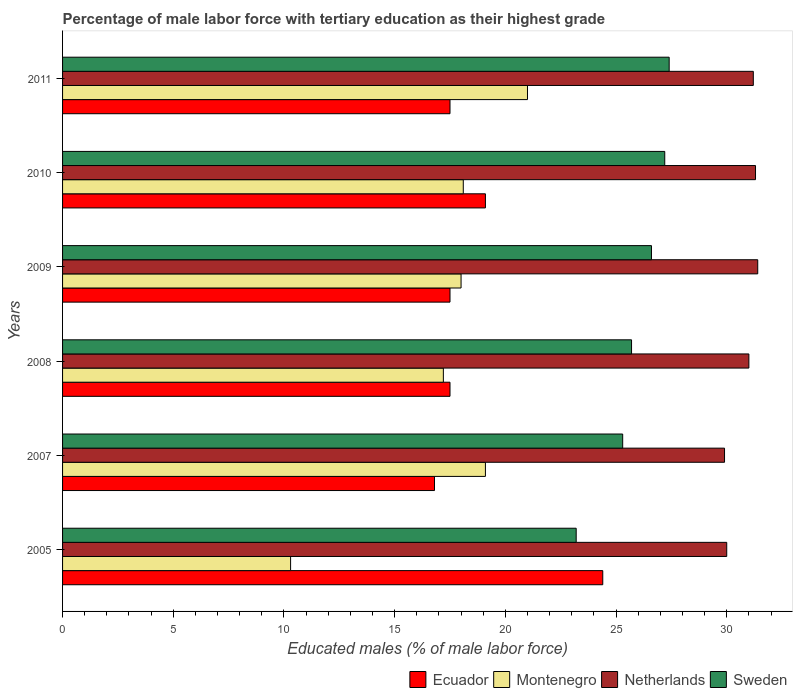How many different coloured bars are there?
Keep it short and to the point. 4. Are the number of bars on each tick of the Y-axis equal?
Keep it short and to the point. Yes. How many bars are there on the 3rd tick from the top?
Provide a short and direct response. 4. What is the percentage of male labor force with tertiary education in Ecuador in 2010?
Make the answer very short. 19.1. Across all years, what is the minimum percentage of male labor force with tertiary education in Sweden?
Offer a terse response. 23.2. In which year was the percentage of male labor force with tertiary education in Netherlands maximum?
Offer a very short reply. 2009. What is the total percentage of male labor force with tertiary education in Montenegro in the graph?
Provide a short and direct response. 103.7. What is the difference between the percentage of male labor force with tertiary education in Montenegro in 2007 and that in 2008?
Provide a succinct answer. 1.9. What is the difference between the percentage of male labor force with tertiary education in Montenegro in 2010 and the percentage of male labor force with tertiary education in Ecuador in 2005?
Keep it short and to the point. -6.3. What is the average percentage of male labor force with tertiary education in Montenegro per year?
Offer a terse response. 17.28. In the year 2010, what is the difference between the percentage of male labor force with tertiary education in Sweden and percentage of male labor force with tertiary education in Netherlands?
Give a very brief answer. -4.1. In how many years, is the percentage of male labor force with tertiary education in Montenegro greater than 25 %?
Your answer should be very brief. 0. What is the ratio of the percentage of male labor force with tertiary education in Sweden in 2010 to that in 2011?
Your response must be concise. 0.99. Is the percentage of male labor force with tertiary education in Ecuador in 2005 less than that in 2007?
Ensure brevity in your answer.  No. Is the difference between the percentage of male labor force with tertiary education in Sweden in 2007 and 2010 greater than the difference between the percentage of male labor force with tertiary education in Netherlands in 2007 and 2010?
Provide a succinct answer. No. What is the difference between the highest and the second highest percentage of male labor force with tertiary education in Sweden?
Provide a succinct answer. 0.2. What is the difference between the highest and the lowest percentage of male labor force with tertiary education in Ecuador?
Offer a terse response. 7.6. Is the sum of the percentage of male labor force with tertiary education in Sweden in 2005 and 2010 greater than the maximum percentage of male labor force with tertiary education in Montenegro across all years?
Your answer should be very brief. Yes. Is it the case that in every year, the sum of the percentage of male labor force with tertiary education in Montenegro and percentage of male labor force with tertiary education in Sweden is greater than the sum of percentage of male labor force with tertiary education in Ecuador and percentage of male labor force with tertiary education in Netherlands?
Provide a succinct answer. No. What does the 4th bar from the bottom in 2011 represents?
Your answer should be very brief. Sweden. Is it the case that in every year, the sum of the percentage of male labor force with tertiary education in Netherlands and percentage of male labor force with tertiary education in Ecuador is greater than the percentage of male labor force with tertiary education in Sweden?
Keep it short and to the point. Yes. What is the difference between two consecutive major ticks on the X-axis?
Provide a succinct answer. 5. Are the values on the major ticks of X-axis written in scientific E-notation?
Provide a succinct answer. No. Where does the legend appear in the graph?
Make the answer very short. Bottom right. How many legend labels are there?
Your answer should be compact. 4. How are the legend labels stacked?
Provide a short and direct response. Horizontal. What is the title of the graph?
Keep it short and to the point. Percentage of male labor force with tertiary education as their highest grade. Does "Marshall Islands" appear as one of the legend labels in the graph?
Your response must be concise. No. What is the label or title of the X-axis?
Keep it short and to the point. Educated males (% of male labor force). What is the Educated males (% of male labor force) in Ecuador in 2005?
Your answer should be very brief. 24.4. What is the Educated males (% of male labor force) in Montenegro in 2005?
Offer a very short reply. 10.3. What is the Educated males (% of male labor force) of Sweden in 2005?
Provide a succinct answer. 23.2. What is the Educated males (% of male labor force) of Ecuador in 2007?
Offer a terse response. 16.8. What is the Educated males (% of male labor force) of Montenegro in 2007?
Provide a short and direct response. 19.1. What is the Educated males (% of male labor force) of Netherlands in 2007?
Provide a short and direct response. 29.9. What is the Educated males (% of male labor force) in Sweden in 2007?
Your response must be concise. 25.3. What is the Educated males (% of male labor force) in Ecuador in 2008?
Keep it short and to the point. 17.5. What is the Educated males (% of male labor force) in Montenegro in 2008?
Offer a very short reply. 17.2. What is the Educated males (% of male labor force) in Netherlands in 2008?
Provide a succinct answer. 31. What is the Educated males (% of male labor force) in Sweden in 2008?
Make the answer very short. 25.7. What is the Educated males (% of male labor force) of Montenegro in 2009?
Your answer should be compact. 18. What is the Educated males (% of male labor force) of Netherlands in 2009?
Provide a short and direct response. 31.4. What is the Educated males (% of male labor force) in Sweden in 2009?
Ensure brevity in your answer.  26.6. What is the Educated males (% of male labor force) in Ecuador in 2010?
Offer a terse response. 19.1. What is the Educated males (% of male labor force) in Montenegro in 2010?
Keep it short and to the point. 18.1. What is the Educated males (% of male labor force) in Netherlands in 2010?
Ensure brevity in your answer.  31.3. What is the Educated males (% of male labor force) of Sweden in 2010?
Keep it short and to the point. 27.2. What is the Educated males (% of male labor force) in Netherlands in 2011?
Give a very brief answer. 31.2. What is the Educated males (% of male labor force) in Sweden in 2011?
Provide a short and direct response. 27.4. Across all years, what is the maximum Educated males (% of male labor force) in Ecuador?
Your answer should be very brief. 24.4. Across all years, what is the maximum Educated males (% of male labor force) in Montenegro?
Provide a succinct answer. 21. Across all years, what is the maximum Educated males (% of male labor force) of Netherlands?
Offer a terse response. 31.4. Across all years, what is the maximum Educated males (% of male labor force) of Sweden?
Provide a succinct answer. 27.4. Across all years, what is the minimum Educated males (% of male labor force) in Ecuador?
Give a very brief answer. 16.8. Across all years, what is the minimum Educated males (% of male labor force) in Montenegro?
Your answer should be compact. 10.3. Across all years, what is the minimum Educated males (% of male labor force) in Netherlands?
Provide a succinct answer. 29.9. Across all years, what is the minimum Educated males (% of male labor force) in Sweden?
Make the answer very short. 23.2. What is the total Educated males (% of male labor force) in Ecuador in the graph?
Keep it short and to the point. 112.8. What is the total Educated males (% of male labor force) in Montenegro in the graph?
Ensure brevity in your answer.  103.7. What is the total Educated males (% of male labor force) in Netherlands in the graph?
Provide a short and direct response. 184.8. What is the total Educated males (% of male labor force) of Sweden in the graph?
Your response must be concise. 155.4. What is the difference between the Educated males (% of male labor force) in Montenegro in 2005 and that in 2007?
Provide a short and direct response. -8.8. What is the difference between the Educated males (% of male labor force) in Sweden in 2005 and that in 2007?
Provide a succinct answer. -2.1. What is the difference between the Educated males (% of male labor force) in Ecuador in 2005 and that in 2008?
Your answer should be very brief. 6.9. What is the difference between the Educated males (% of male labor force) of Montenegro in 2005 and that in 2008?
Your answer should be very brief. -6.9. What is the difference between the Educated males (% of male labor force) in Netherlands in 2005 and that in 2008?
Offer a terse response. -1. What is the difference between the Educated males (% of male labor force) in Sweden in 2005 and that in 2008?
Offer a very short reply. -2.5. What is the difference between the Educated males (% of male labor force) of Netherlands in 2005 and that in 2010?
Give a very brief answer. -1.3. What is the difference between the Educated males (% of male labor force) of Sweden in 2005 and that in 2010?
Offer a very short reply. -4. What is the difference between the Educated males (% of male labor force) in Ecuador in 2005 and that in 2011?
Your answer should be very brief. 6.9. What is the difference between the Educated males (% of male labor force) of Netherlands in 2005 and that in 2011?
Make the answer very short. -1.2. What is the difference between the Educated males (% of male labor force) of Montenegro in 2007 and that in 2008?
Provide a succinct answer. 1.9. What is the difference between the Educated males (% of male labor force) of Netherlands in 2007 and that in 2008?
Your response must be concise. -1.1. What is the difference between the Educated males (% of male labor force) of Sweden in 2007 and that in 2008?
Make the answer very short. -0.4. What is the difference between the Educated males (% of male labor force) of Ecuador in 2007 and that in 2009?
Make the answer very short. -0.7. What is the difference between the Educated males (% of male labor force) of Montenegro in 2007 and that in 2009?
Ensure brevity in your answer.  1.1. What is the difference between the Educated males (% of male labor force) of Sweden in 2007 and that in 2009?
Offer a terse response. -1.3. What is the difference between the Educated males (% of male labor force) in Montenegro in 2007 and that in 2010?
Provide a short and direct response. 1. What is the difference between the Educated males (% of male labor force) of Ecuador in 2007 and that in 2011?
Your answer should be compact. -0.7. What is the difference between the Educated males (% of male labor force) of Montenegro in 2007 and that in 2011?
Ensure brevity in your answer.  -1.9. What is the difference between the Educated males (% of male labor force) of Montenegro in 2008 and that in 2009?
Offer a terse response. -0.8. What is the difference between the Educated males (% of male labor force) of Sweden in 2008 and that in 2009?
Provide a succinct answer. -0.9. What is the difference between the Educated males (% of male labor force) in Ecuador in 2008 and that in 2010?
Provide a succinct answer. -1.6. What is the difference between the Educated males (% of male labor force) in Netherlands in 2008 and that in 2010?
Make the answer very short. -0.3. What is the difference between the Educated males (% of male labor force) of Montenegro in 2008 and that in 2011?
Keep it short and to the point. -3.8. What is the difference between the Educated males (% of male labor force) in Netherlands in 2008 and that in 2011?
Your answer should be compact. -0.2. What is the difference between the Educated males (% of male labor force) in Sweden in 2008 and that in 2011?
Make the answer very short. -1.7. What is the difference between the Educated males (% of male labor force) of Ecuador in 2009 and that in 2010?
Offer a terse response. -1.6. What is the difference between the Educated males (% of male labor force) of Ecuador in 2009 and that in 2011?
Give a very brief answer. 0. What is the difference between the Educated males (% of male labor force) in Ecuador in 2010 and that in 2011?
Give a very brief answer. 1.6. What is the difference between the Educated males (% of male labor force) in Montenegro in 2010 and that in 2011?
Your answer should be very brief. -2.9. What is the difference between the Educated males (% of male labor force) in Sweden in 2010 and that in 2011?
Provide a succinct answer. -0.2. What is the difference between the Educated males (% of male labor force) in Ecuador in 2005 and the Educated males (% of male labor force) in Montenegro in 2007?
Make the answer very short. 5.3. What is the difference between the Educated males (% of male labor force) of Ecuador in 2005 and the Educated males (% of male labor force) of Netherlands in 2007?
Your answer should be very brief. -5.5. What is the difference between the Educated males (% of male labor force) in Ecuador in 2005 and the Educated males (% of male labor force) in Sweden in 2007?
Offer a terse response. -0.9. What is the difference between the Educated males (% of male labor force) in Montenegro in 2005 and the Educated males (% of male labor force) in Netherlands in 2007?
Keep it short and to the point. -19.6. What is the difference between the Educated males (% of male labor force) of Netherlands in 2005 and the Educated males (% of male labor force) of Sweden in 2007?
Your response must be concise. 4.7. What is the difference between the Educated males (% of male labor force) in Ecuador in 2005 and the Educated males (% of male labor force) in Netherlands in 2008?
Make the answer very short. -6.6. What is the difference between the Educated males (% of male labor force) of Montenegro in 2005 and the Educated males (% of male labor force) of Netherlands in 2008?
Your response must be concise. -20.7. What is the difference between the Educated males (% of male labor force) in Montenegro in 2005 and the Educated males (% of male labor force) in Sweden in 2008?
Your answer should be compact. -15.4. What is the difference between the Educated males (% of male labor force) in Netherlands in 2005 and the Educated males (% of male labor force) in Sweden in 2008?
Your answer should be very brief. 4.3. What is the difference between the Educated males (% of male labor force) of Ecuador in 2005 and the Educated males (% of male labor force) of Montenegro in 2009?
Provide a succinct answer. 6.4. What is the difference between the Educated males (% of male labor force) in Ecuador in 2005 and the Educated males (% of male labor force) in Netherlands in 2009?
Ensure brevity in your answer.  -7. What is the difference between the Educated males (% of male labor force) in Montenegro in 2005 and the Educated males (% of male labor force) in Netherlands in 2009?
Ensure brevity in your answer.  -21.1. What is the difference between the Educated males (% of male labor force) in Montenegro in 2005 and the Educated males (% of male labor force) in Sweden in 2009?
Keep it short and to the point. -16.3. What is the difference between the Educated males (% of male labor force) in Ecuador in 2005 and the Educated males (% of male labor force) in Montenegro in 2010?
Give a very brief answer. 6.3. What is the difference between the Educated males (% of male labor force) of Montenegro in 2005 and the Educated males (% of male labor force) of Sweden in 2010?
Keep it short and to the point. -16.9. What is the difference between the Educated males (% of male labor force) in Netherlands in 2005 and the Educated males (% of male labor force) in Sweden in 2010?
Provide a short and direct response. 2.8. What is the difference between the Educated males (% of male labor force) in Ecuador in 2005 and the Educated males (% of male labor force) in Netherlands in 2011?
Ensure brevity in your answer.  -6.8. What is the difference between the Educated males (% of male labor force) of Ecuador in 2005 and the Educated males (% of male labor force) of Sweden in 2011?
Ensure brevity in your answer.  -3. What is the difference between the Educated males (% of male labor force) in Montenegro in 2005 and the Educated males (% of male labor force) in Netherlands in 2011?
Make the answer very short. -20.9. What is the difference between the Educated males (% of male labor force) in Montenegro in 2005 and the Educated males (% of male labor force) in Sweden in 2011?
Provide a short and direct response. -17.1. What is the difference between the Educated males (% of male labor force) of Ecuador in 2007 and the Educated males (% of male labor force) of Netherlands in 2008?
Keep it short and to the point. -14.2. What is the difference between the Educated males (% of male labor force) of Ecuador in 2007 and the Educated males (% of male labor force) of Sweden in 2008?
Give a very brief answer. -8.9. What is the difference between the Educated males (% of male labor force) of Montenegro in 2007 and the Educated males (% of male labor force) of Sweden in 2008?
Offer a very short reply. -6.6. What is the difference between the Educated males (% of male labor force) of Ecuador in 2007 and the Educated males (% of male labor force) of Netherlands in 2009?
Keep it short and to the point. -14.6. What is the difference between the Educated males (% of male labor force) in Montenegro in 2007 and the Educated males (% of male labor force) in Netherlands in 2009?
Your answer should be very brief. -12.3. What is the difference between the Educated males (% of male labor force) of Montenegro in 2007 and the Educated males (% of male labor force) of Sweden in 2009?
Ensure brevity in your answer.  -7.5. What is the difference between the Educated males (% of male labor force) in Ecuador in 2007 and the Educated males (% of male labor force) in Montenegro in 2010?
Provide a succinct answer. -1.3. What is the difference between the Educated males (% of male labor force) of Ecuador in 2007 and the Educated males (% of male labor force) of Sweden in 2010?
Your response must be concise. -10.4. What is the difference between the Educated males (% of male labor force) of Montenegro in 2007 and the Educated males (% of male labor force) of Netherlands in 2010?
Give a very brief answer. -12.2. What is the difference between the Educated males (% of male labor force) of Ecuador in 2007 and the Educated males (% of male labor force) of Netherlands in 2011?
Provide a succinct answer. -14.4. What is the difference between the Educated males (% of male labor force) in Ecuador in 2007 and the Educated males (% of male labor force) in Sweden in 2011?
Give a very brief answer. -10.6. What is the difference between the Educated males (% of male labor force) of Montenegro in 2007 and the Educated males (% of male labor force) of Netherlands in 2011?
Offer a very short reply. -12.1. What is the difference between the Educated males (% of male labor force) in Montenegro in 2007 and the Educated males (% of male labor force) in Sweden in 2011?
Your answer should be compact. -8.3. What is the difference between the Educated males (% of male labor force) in Ecuador in 2008 and the Educated males (% of male labor force) in Montenegro in 2009?
Provide a short and direct response. -0.5. What is the difference between the Educated males (% of male labor force) in Montenegro in 2008 and the Educated males (% of male labor force) in Netherlands in 2009?
Ensure brevity in your answer.  -14.2. What is the difference between the Educated males (% of male labor force) of Montenegro in 2008 and the Educated males (% of male labor force) of Sweden in 2009?
Your answer should be very brief. -9.4. What is the difference between the Educated males (% of male labor force) in Netherlands in 2008 and the Educated males (% of male labor force) in Sweden in 2009?
Your answer should be very brief. 4.4. What is the difference between the Educated males (% of male labor force) of Ecuador in 2008 and the Educated males (% of male labor force) of Montenegro in 2010?
Give a very brief answer. -0.6. What is the difference between the Educated males (% of male labor force) in Ecuador in 2008 and the Educated males (% of male labor force) in Sweden in 2010?
Make the answer very short. -9.7. What is the difference between the Educated males (% of male labor force) of Montenegro in 2008 and the Educated males (% of male labor force) of Netherlands in 2010?
Provide a succinct answer. -14.1. What is the difference between the Educated males (% of male labor force) of Montenegro in 2008 and the Educated males (% of male labor force) of Sweden in 2010?
Keep it short and to the point. -10. What is the difference between the Educated males (% of male labor force) in Netherlands in 2008 and the Educated males (% of male labor force) in Sweden in 2010?
Give a very brief answer. 3.8. What is the difference between the Educated males (% of male labor force) in Ecuador in 2008 and the Educated males (% of male labor force) in Netherlands in 2011?
Provide a short and direct response. -13.7. What is the difference between the Educated males (% of male labor force) in Montenegro in 2008 and the Educated males (% of male labor force) in Netherlands in 2011?
Give a very brief answer. -14. What is the difference between the Educated males (% of male labor force) in Montenegro in 2008 and the Educated males (% of male labor force) in Sweden in 2011?
Keep it short and to the point. -10.2. What is the difference between the Educated males (% of male labor force) of Ecuador in 2009 and the Educated males (% of male labor force) of Montenegro in 2010?
Offer a terse response. -0.6. What is the difference between the Educated males (% of male labor force) of Montenegro in 2009 and the Educated males (% of male labor force) of Sweden in 2010?
Ensure brevity in your answer.  -9.2. What is the difference between the Educated males (% of male labor force) in Netherlands in 2009 and the Educated males (% of male labor force) in Sweden in 2010?
Provide a succinct answer. 4.2. What is the difference between the Educated males (% of male labor force) in Ecuador in 2009 and the Educated males (% of male labor force) in Netherlands in 2011?
Give a very brief answer. -13.7. What is the difference between the Educated males (% of male labor force) in Montenegro in 2009 and the Educated males (% of male labor force) in Netherlands in 2011?
Your response must be concise. -13.2. What is the difference between the Educated males (% of male labor force) of Ecuador in 2010 and the Educated males (% of male labor force) of Netherlands in 2011?
Give a very brief answer. -12.1. What is the difference between the Educated males (% of male labor force) of Ecuador in 2010 and the Educated males (% of male labor force) of Sweden in 2011?
Provide a short and direct response. -8.3. What is the difference between the Educated males (% of male labor force) of Montenegro in 2010 and the Educated males (% of male labor force) of Sweden in 2011?
Make the answer very short. -9.3. What is the average Educated males (% of male labor force) in Montenegro per year?
Your response must be concise. 17.28. What is the average Educated males (% of male labor force) in Netherlands per year?
Your answer should be very brief. 30.8. What is the average Educated males (% of male labor force) in Sweden per year?
Offer a very short reply. 25.9. In the year 2005, what is the difference between the Educated males (% of male labor force) in Ecuador and Educated males (% of male labor force) in Montenegro?
Your answer should be very brief. 14.1. In the year 2005, what is the difference between the Educated males (% of male labor force) of Ecuador and Educated males (% of male labor force) of Netherlands?
Offer a terse response. -5.6. In the year 2005, what is the difference between the Educated males (% of male labor force) in Ecuador and Educated males (% of male labor force) in Sweden?
Your answer should be very brief. 1.2. In the year 2005, what is the difference between the Educated males (% of male labor force) of Montenegro and Educated males (% of male labor force) of Netherlands?
Offer a very short reply. -19.7. In the year 2005, what is the difference between the Educated males (% of male labor force) of Montenegro and Educated males (% of male labor force) of Sweden?
Keep it short and to the point. -12.9. In the year 2007, what is the difference between the Educated males (% of male labor force) in Ecuador and Educated males (% of male labor force) in Montenegro?
Make the answer very short. -2.3. In the year 2007, what is the difference between the Educated males (% of male labor force) of Ecuador and Educated males (% of male labor force) of Netherlands?
Ensure brevity in your answer.  -13.1. In the year 2007, what is the difference between the Educated males (% of male labor force) in Ecuador and Educated males (% of male labor force) in Sweden?
Make the answer very short. -8.5. In the year 2007, what is the difference between the Educated males (% of male labor force) of Montenegro and Educated males (% of male labor force) of Netherlands?
Provide a short and direct response. -10.8. In the year 2008, what is the difference between the Educated males (% of male labor force) in Ecuador and Educated males (% of male labor force) in Netherlands?
Give a very brief answer. -13.5. In the year 2008, what is the difference between the Educated males (% of male labor force) in Montenegro and Educated males (% of male labor force) in Netherlands?
Make the answer very short. -13.8. In the year 2009, what is the difference between the Educated males (% of male labor force) of Ecuador and Educated males (% of male labor force) of Montenegro?
Offer a very short reply. -0.5. In the year 2009, what is the difference between the Educated males (% of male labor force) of Ecuador and Educated males (% of male labor force) of Netherlands?
Your answer should be very brief. -13.9. In the year 2009, what is the difference between the Educated males (% of male labor force) of Ecuador and Educated males (% of male labor force) of Sweden?
Make the answer very short. -9.1. In the year 2009, what is the difference between the Educated males (% of male labor force) of Montenegro and Educated males (% of male labor force) of Netherlands?
Your response must be concise. -13.4. In the year 2009, what is the difference between the Educated males (% of male labor force) of Montenegro and Educated males (% of male labor force) of Sweden?
Provide a succinct answer. -8.6. In the year 2009, what is the difference between the Educated males (% of male labor force) of Netherlands and Educated males (% of male labor force) of Sweden?
Provide a short and direct response. 4.8. In the year 2010, what is the difference between the Educated males (% of male labor force) in Ecuador and Educated males (% of male labor force) in Montenegro?
Your answer should be compact. 1. In the year 2010, what is the difference between the Educated males (% of male labor force) of Ecuador and Educated males (% of male labor force) of Sweden?
Your answer should be compact. -8.1. In the year 2010, what is the difference between the Educated males (% of male labor force) of Montenegro and Educated males (% of male labor force) of Sweden?
Your answer should be compact. -9.1. In the year 2010, what is the difference between the Educated males (% of male labor force) in Netherlands and Educated males (% of male labor force) in Sweden?
Make the answer very short. 4.1. In the year 2011, what is the difference between the Educated males (% of male labor force) in Ecuador and Educated males (% of male labor force) in Netherlands?
Offer a terse response. -13.7. In the year 2011, what is the difference between the Educated males (% of male labor force) in Ecuador and Educated males (% of male labor force) in Sweden?
Your answer should be very brief. -9.9. In the year 2011, what is the difference between the Educated males (% of male labor force) of Montenegro and Educated males (% of male labor force) of Netherlands?
Provide a succinct answer. -10.2. What is the ratio of the Educated males (% of male labor force) of Ecuador in 2005 to that in 2007?
Keep it short and to the point. 1.45. What is the ratio of the Educated males (% of male labor force) in Montenegro in 2005 to that in 2007?
Offer a terse response. 0.54. What is the ratio of the Educated males (% of male labor force) of Sweden in 2005 to that in 2007?
Keep it short and to the point. 0.92. What is the ratio of the Educated males (% of male labor force) in Ecuador in 2005 to that in 2008?
Offer a terse response. 1.39. What is the ratio of the Educated males (% of male labor force) in Montenegro in 2005 to that in 2008?
Provide a succinct answer. 0.6. What is the ratio of the Educated males (% of male labor force) of Netherlands in 2005 to that in 2008?
Your answer should be very brief. 0.97. What is the ratio of the Educated males (% of male labor force) in Sweden in 2005 to that in 2008?
Offer a terse response. 0.9. What is the ratio of the Educated males (% of male labor force) of Ecuador in 2005 to that in 2009?
Your response must be concise. 1.39. What is the ratio of the Educated males (% of male labor force) in Montenegro in 2005 to that in 2009?
Offer a terse response. 0.57. What is the ratio of the Educated males (% of male labor force) in Netherlands in 2005 to that in 2009?
Your answer should be compact. 0.96. What is the ratio of the Educated males (% of male labor force) in Sweden in 2005 to that in 2009?
Your response must be concise. 0.87. What is the ratio of the Educated males (% of male labor force) in Ecuador in 2005 to that in 2010?
Your answer should be very brief. 1.28. What is the ratio of the Educated males (% of male labor force) in Montenegro in 2005 to that in 2010?
Provide a short and direct response. 0.57. What is the ratio of the Educated males (% of male labor force) in Netherlands in 2005 to that in 2010?
Offer a very short reply. 0.96. What is the ratio of the Educated males (% of male labor force) of Sweden in 2005 to that in 2010?
Provide a succinct answer. 0.85. What is the ratio of the Educated males (% of male labor force) of Ecuador in 2005 to that in 2011?
Offer a very short reply. 1.39. What is the ratio of the Educated males (% of male labor force) in Montenegro in 2005 to that in 2011?
Ensure brevity in your answer.  0.49. What is the ratio of the Educated males (% of male labor force) in Netherlands in 2005 to that in 2011?
Keep it short and to the point. 0.96. What is the ratio of the Educated males (% of male labor force) of Sweden in 2005 to that in 2011?
Ensure brevity in your answer.  0.85. What is the ratio of the Educated males (% of male labor force) in Ecuador in 2007 to that in 2008?
Your answer should be compact. 0.96. What is the ratio of the Educated males (% of male labor force) of Montenegro in 2007 to that in 2008?
Provide a succinct answer. 1.11. What is the ratio of the Educated males (% of male labor force) of Netherlands in 2007 to that in 2008?
Ensure brevity in your answer.  0.96. What is the ratio of the Educated males (% of male labor force) in Sweden in 2007 to that in 2008?
Provide a short and direct response. 0.98. What is the ratio of the Educated males (% of male labor force) in Montenegro in 2007 to that in 2009?
Your answer should be very brief. 1.06. What is the ratio of the Educated males (% of male labor force) in Netherlands in 2007 to that in 2009?
Offer a very short reply. 0.95. What is the ratio of the Educated males (% of male labor force) in Sweden in 2007 to that in 2009?
Make the answer very short. 0.95. What is the ratio of the Educated males (% of male labor force) of Ecuador in 2007 to that in 2010?
Your response must be concise. 0.88. What is the ratio of the Educated males (% of male labor force) of Montenegro in 2007 to that in 2010?
Your answer should be compact. 1.06. What is the ratio of the Educated males (% of male labor force) in Netherlands in 2007 to that in 2010?
Give a very brief answer. 0.96. What is the ratio of the Educated males (% of male labor force) of Sweden in 2007 to that in 2010?
Your answer should be compact. 0.93. What is the ratio of the Educated males (% of male labor force) of Ecuador in 2007 to that in 2011?
Offer a very short reply. 0.96. What is the ratio of the Educated males (% of male labor force) in Montenegro in 2007 to that in 2011?
Give a very brief answer. 0.91. What is the ratio of the Educated males (% of male labor force) in Sweden in 2007 to that in 2011?
Offer a very short reply. 0.92. What is the ratio of the Educated males (% of male labor force) in Montenegro in 2008 to that in 2009?
Ensure brevity in your answer.  0.96. What is the ratio of the Educated males (% of male labor force) in Netherlands in 2008 to that in 2009?
Your answer should be very brief. 0.99. What is the ratio of the Educated males (% of male labor force) in Sweden in 2008 to that in 2009?
Provide a succinct answer. 0.97. What is the ratio of the Educated males (% of male labor force) of Ecuador in 2008 to that in 2010?
Offer a terse response. 0.92. What is the ratio of the Educated males (% of male labor force) of Montenegro in 2008 to that in 2010?
Offer a very short reply. 0.95. What is the ratio of the Educated males (% of male labor force) of Sweden in 2008 to that in 2010?
Give a very brief answer. 0.94. What is the ratio of the Educated males (% of male labor force) in Montenegro in 2008 to that in 2011?
Your answer should be compact. 0.82. What is the ratio of the Educated males (% of male labor force) in Sweden in 2008 to that in 2011?
Your answer should be compact. 0.94. What is the ratio of the Educated males (% of male labor force) of Ecuador in 2009 to that in 2010?
Give a very brief answer. 0.92. What is the ratio of the Educated males (% of male labor force) of Montenegro in 2009 to that in 2010?
Ensure brevity in your answer.  0.99. What is the ratio of the Educated males (% of male labor force) of Sweden in 2009 to that in 2010?
Your answer should be compact. 0.98. What is the ratio of the Educated males (% of male labor force) of Ecuador in 2009 to that in 2011?
Your response must be concise. 1. What is the ratio of the Educated males (% of male labor force) in Montenegro in 2009 to that in 2011?
Ensure brevity in your answer.  0.86. What is the ratio of the Educated males (% of male labor force) of Netherlands in 2009 to that in 2011?
Make the answer very short. 1.01. What is the ratio of the Educated males (% of male labor force) of Sweden in 2009 to that in 2011?
Offer a very short reply. 0.97. What is the ratio of the Educated males (% of male labor force) of Ecuador in 2010 to that in 2011?
Your answer should be compact. 1.09. What is the ratio of the Educated males (% of male labor force) of Montenegro in 2010 to that in 2011?
Keep it short and to the point. 0.86. What is the ratio of the Educated males (% of male labor force) in Sweden in 2010 to that in 2011?
Offer a terse response. 0.99. What is the difference between the highest and the second highest Educated males (% of male labor force) in Ecuador?
Your response must be concise. 5.3. What is the difference between the highest and the second highest Educated males (% of male labor force) in Netherlands?
Keep it short and to the point. 0.1. What is the difference between the highest and the lowest Educated males (% of male labor force) of Ecuador?
Your answer should be compact. 7.6. What is the difference between the highest and the lowest Educated males (% of male labor force) of Montenegro?
Give a very brief answer. 10.7. What is the difference between the highest and the lowest Educated males (% of male labor force) in Netherlands?
Your answer should be very brief. 1.5. What is the difference between the highest and the lowest Educated males (% of male labor force) of Sweden?
Keep it short and to the point. 4.2. 